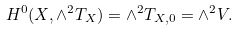<formula> <loc_0><loc_0><loc_500><loc_500>H ^ { 0 } ( X , \wedge ^ { 2 } T _ { X } ) = \wedge ^ { 2 } T _ { X , 0 } = \wedge ^ { 2 } V .</formula> 